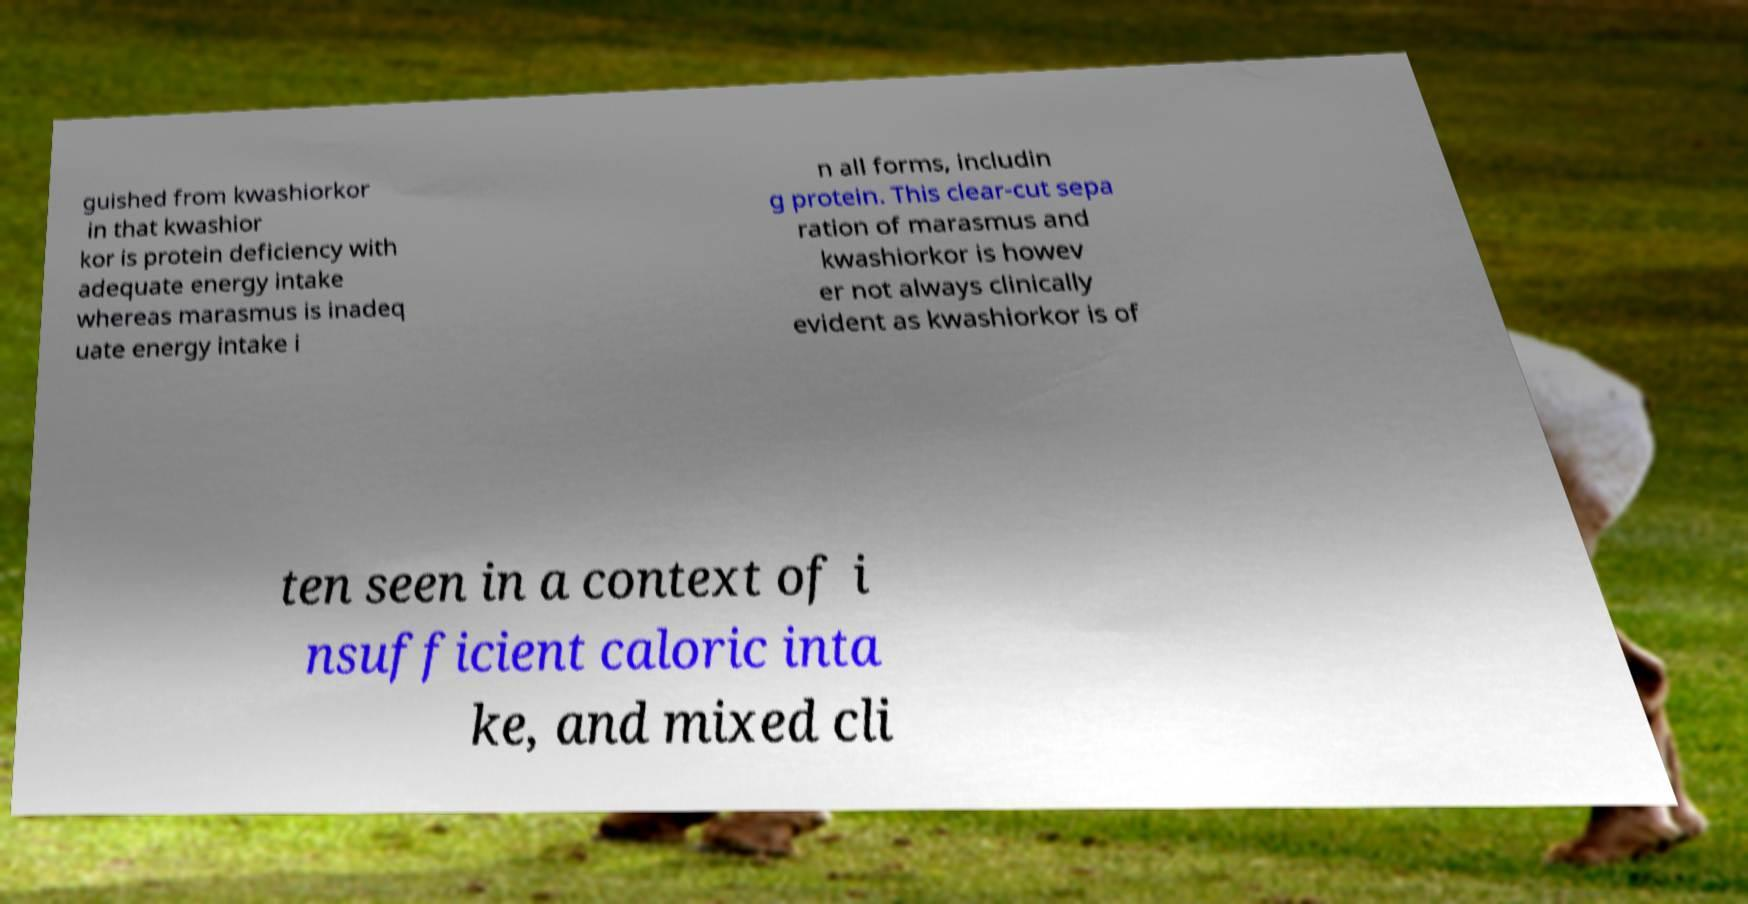Could you assist in decoding the text presented in this image and type it out clearly? guished from kwashiorkor in that kwashior kor is protein deficiency with adequate energy intake whereas marasmus is inadeq uate energy intake i n all forms, includin g protein. This clear-cut sepa ration of marasmus and kwashiorkor is howev er not always clinically evident as kwashiorkor is of ten seen in a context of i nsufficient caloric inta ke, and mixed cli 